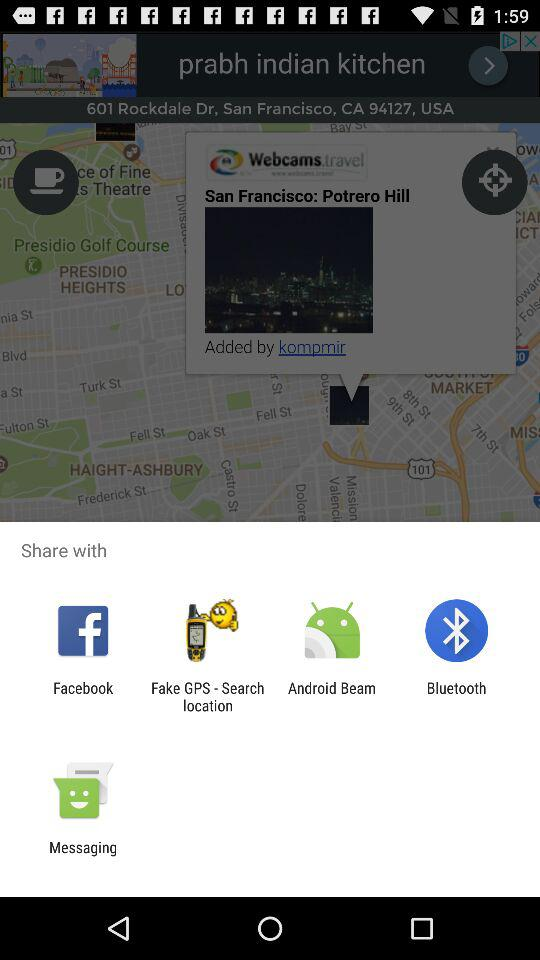What sharing options are available? The available sharing options are "Facebook", "Fake GPS - Search location", "Android Beam", "Bluetooth" and "Messaging". 